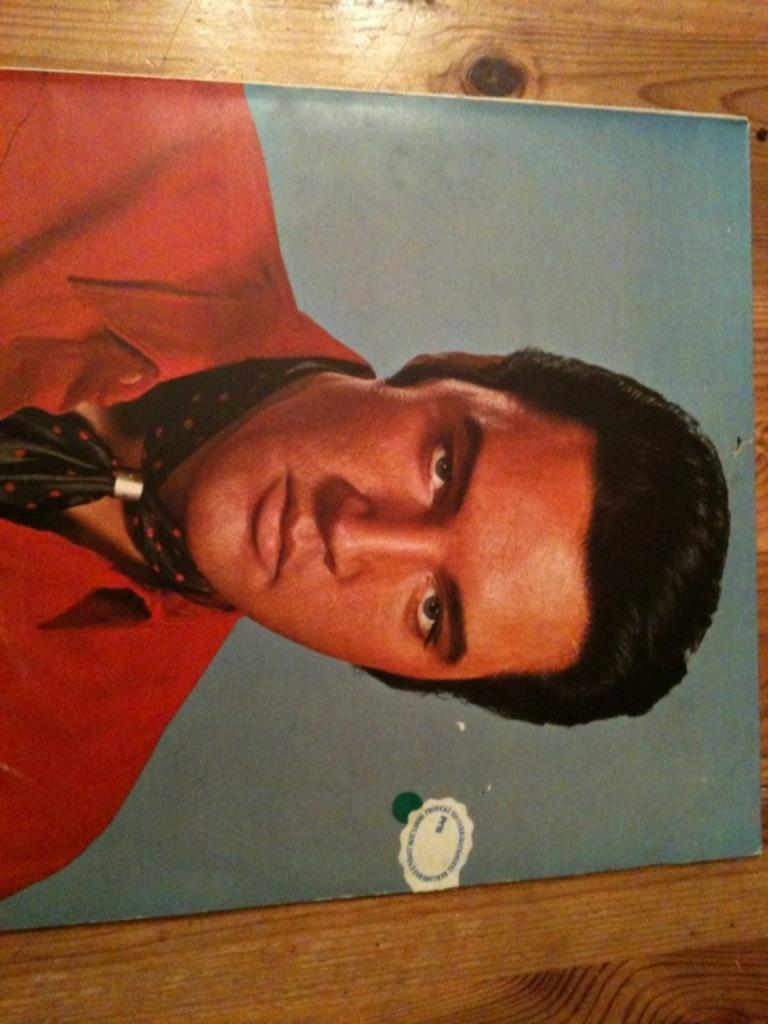What object is present in the image that typically holds a photograph? There is a photo frame in the image. Where is the photo frame located? The photo frame is placed on a brown table. What can be seen inside the photo frame? The photo frame contains an image of a man. What is the man in the photo wearing? The man in the photo is wearing a red shirt. What type of protest is happening in the image? There is no protest present in the image; it features a photo frame with an image of a man wearing a red shirt. Can you hear the man in the photo whistling in the image? There is no sound in the image, so it is not possible to determine if the man in the photo is whistling. 